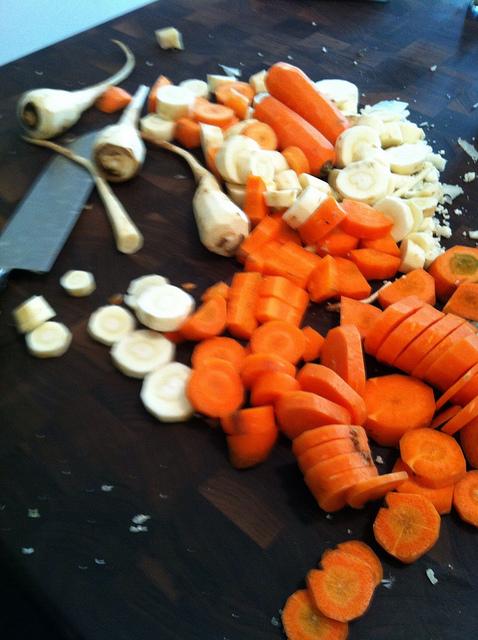Have these vegetables been cooked?
Give a very brief answer. No. What colors do you see?
Give a very brief answer. Orange and white. What other vegetables are there besides carrots?
Write a very short answer. Garlic. 